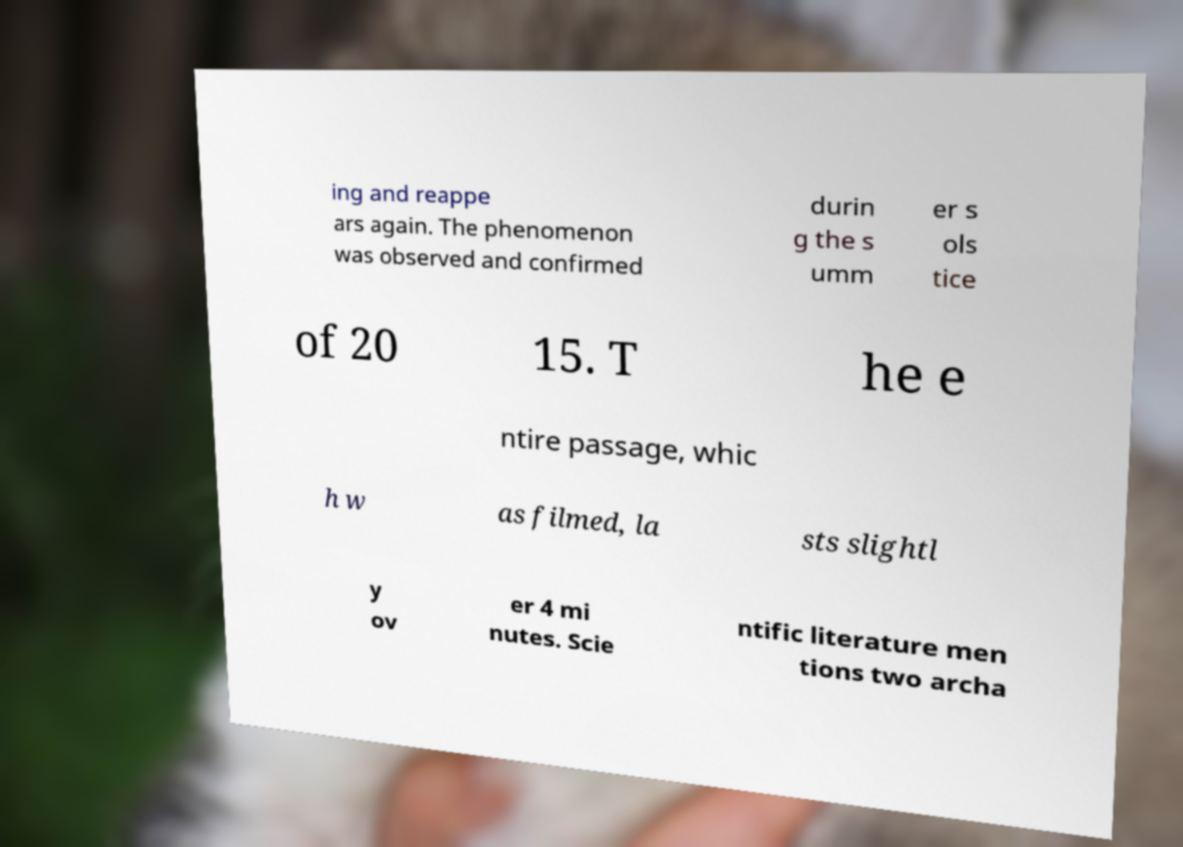Could you extract and type out the text from this image? ing and reappe ars again. The phenomenon was observed and confirmed durin g the s umm er s ols tice of 20 15. T he e ntire passage, whic h w as filmed, la sts slightl y ov er 4 mi nutes. Scie ntific literature men tions two archa 